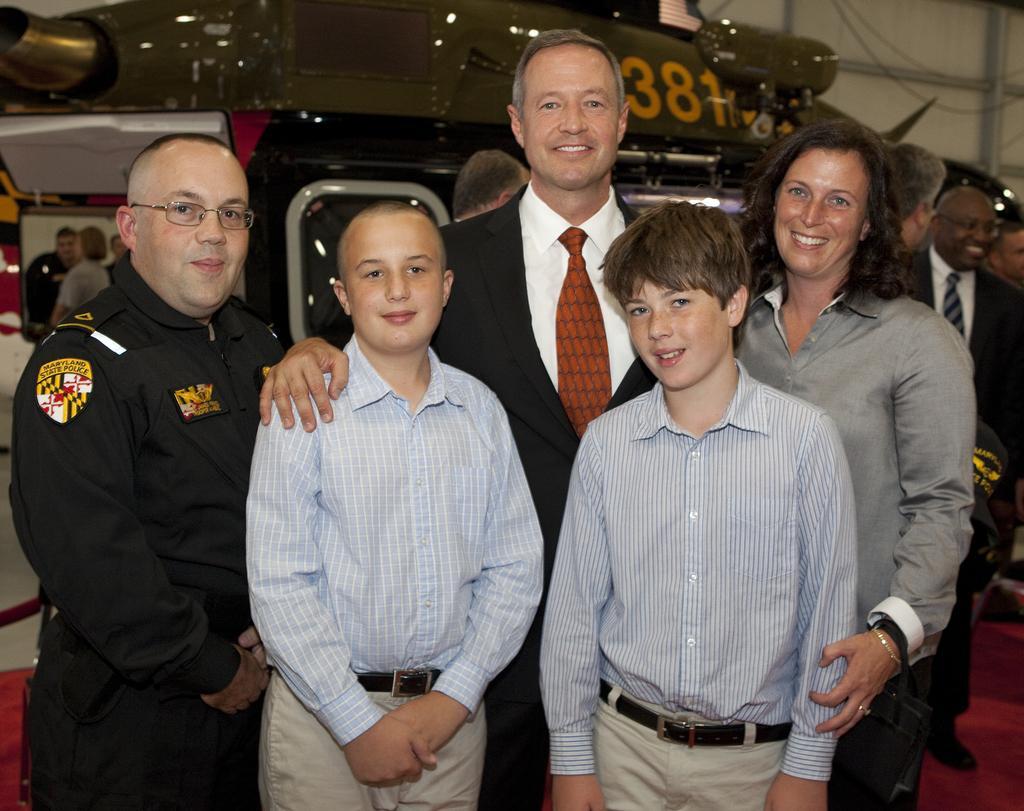In one or two sentences, can you explain what this image depicts? In this picture there are people those who are standing in the center of the image, there are other people behind them. 